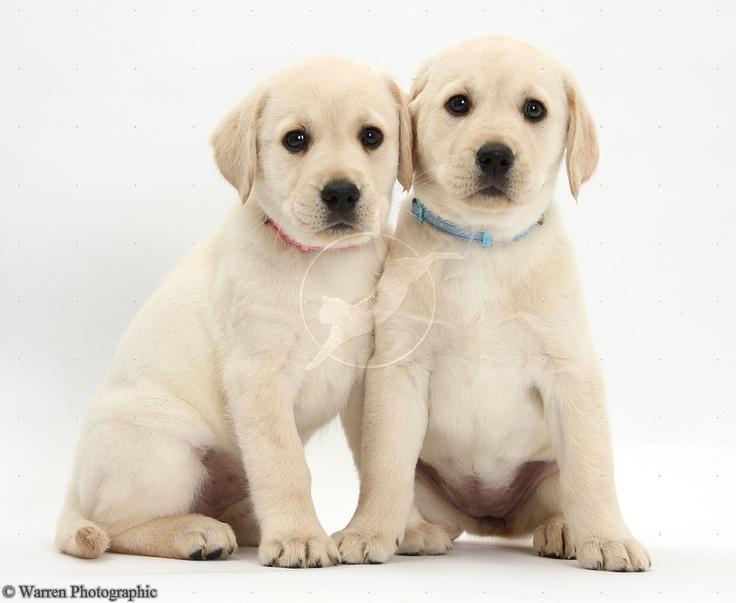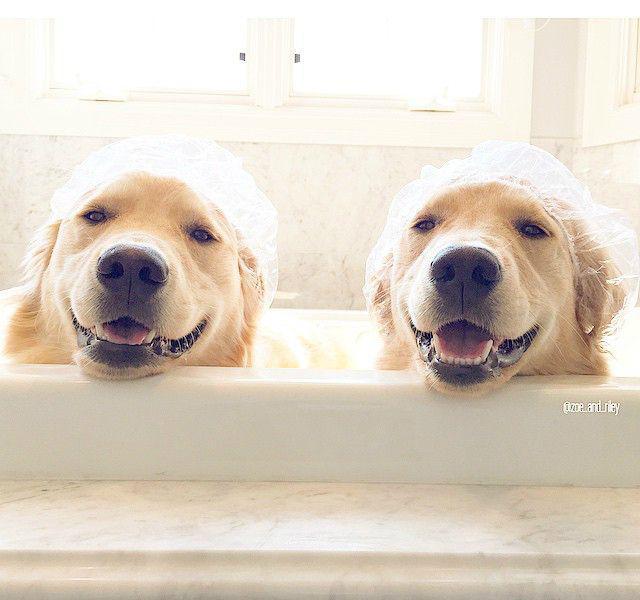The first image is the image on the left, the second image is the image on the right. Analyze the images presented: Is the assertion "Exactly seven dogs are shown, in groups of two and five." valid? Answer yes or no. No. The first image is the image on the left, the second image is the image on the right. Analyze the images presented: Is the assertion "One image shows a group of five sitting and reclining puppies in an indoor setting." valid? Answer yes or no. No. 